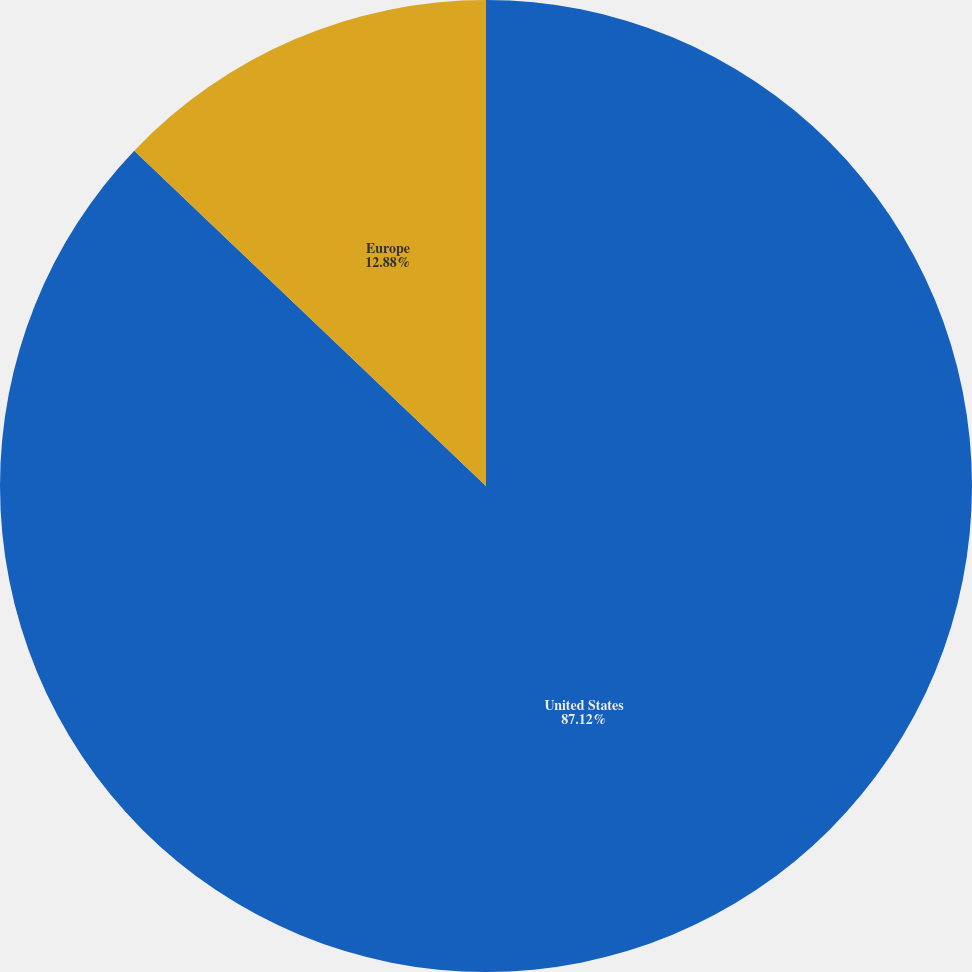Convert chart to OTSL. <chart><loc_0><loc_0><loc_500><loc_500><pie_chart><fcel>United States<fcel>Europe<nl><fcel>87.12%<fcel>12.88%<nl></chart> 